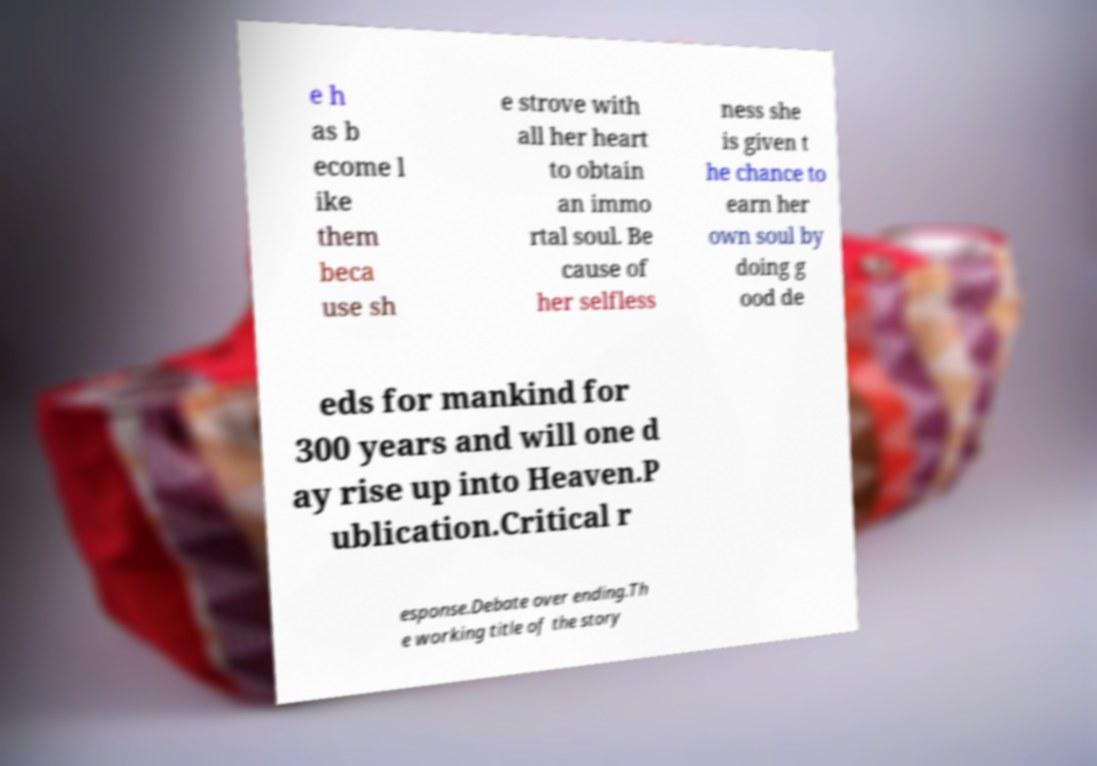I need the written content from this picture converted into text. Can you do that? e h as b ecome l ike them beca use sh e strove with all her heart to obtain an immo rtal soul. Be cause of her selfless ness she is given t he chance to earn her own soul by doing g ood de eds for mankind for 300 years and will one d ay rise up into Heaven.P ublication.Critical r esponse.Debate over ending.Th e working title of the story 